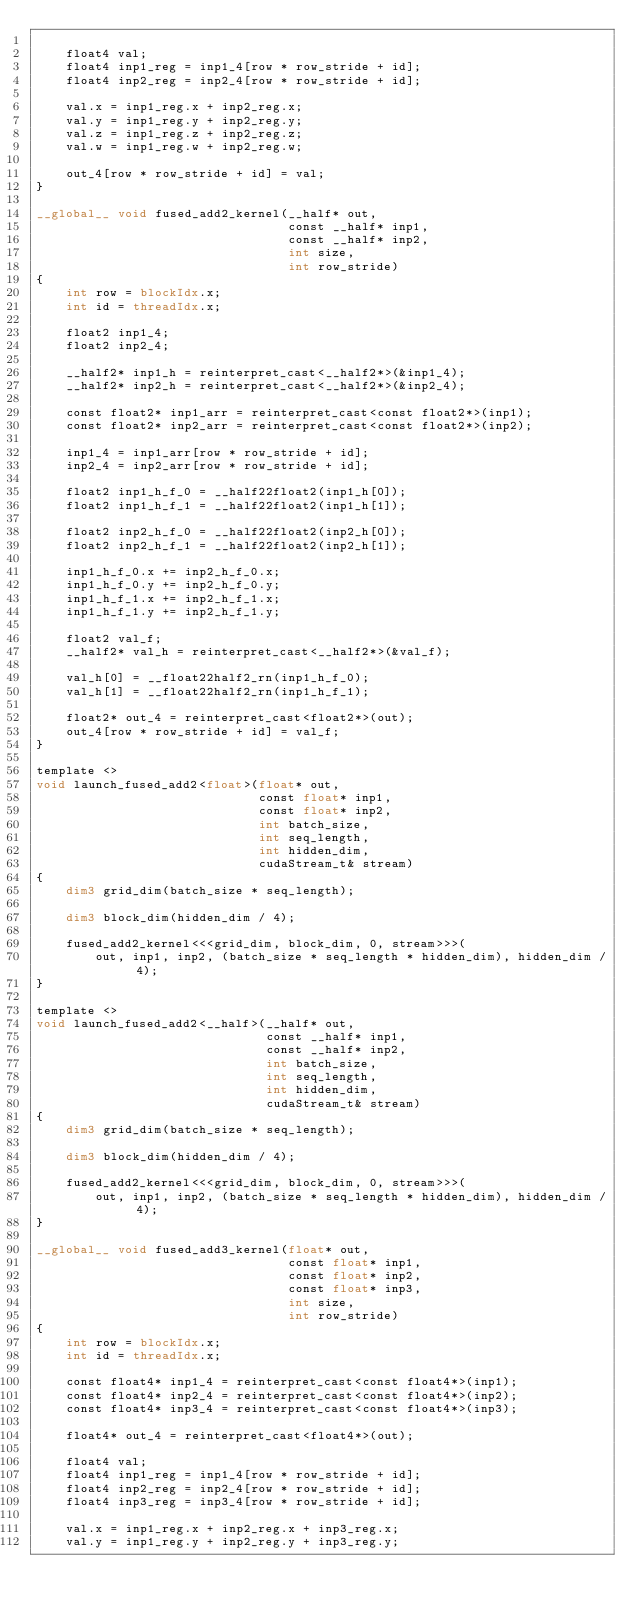<code> <loc_0><loc_0><loc_500><loc_500><_Cuda_>
    float4 val;
    float4 inp1_reg = inp1_4[row * row_stride + id];
    float4 inp2_reg = inp2_4[row * row_stride + id];

    val.x = inp1_reg.x + inp2_reg.x;
    val.y = inp1_reg.y + inp2_reg.y;
    val.z = inp1_reg.z + inp2_reg.z;
    val.w = inp1_reg.w + inp2_reg.w;

    out_4[row * row_stride + id] = val;
}

__global__ void fused_add2_kernel(__half* out,
                                  const __half* inp1,
                                  const __half* inp2,
                                  int size,
                                  int row_stride)
{
    int row = blockIdx.x;
    int id = threadIdx.x;

    float2 inp1_4;
    float2 inp2_4;

    __half2* inp1_h = reinterpret_cast<__half2*>(&inp1_4);
    __half2* inp2_h = reinterpret_cast<__half2*>(&inp2_4);

    const float2* inp1_arr = reinterpret_cast<const float2*>(inp1);
    const float2* inp2_arr = reinterpret_cast<const float2*>(inp2);

    inp1_4 = inp1_arr[row * row_stride + id];
    inp2_4 = inp2_arr[row * row_stride + id];

    float2 inp1_h_f_0 = __half22float2(inp1_h[0]);
    float2 inp1_h_f_1 = __half22float2(inp1_h[1]);

    float2 inp2_h_f_0 = __half22float2(inp2_h[0]);
    float2 inp2_h_f_1 = __half22float2(inp2_h[1]);

    inp1_h_f_0.x += inp2_h_f_0.x;
    inp1_h_f_0.y += inp2_h_f_0.y;
    inp1_h_f_1.x += inp2_h_f_1.x;
    inp1_h_f_1.y += inp2_h_f_1.y;

    float2 val_f;
    __half2* val_h = reinterpret_cast<__half2*>(&val_f);

    val_h[0] = __float22half2_rn(inp1_h_f_0);
    val_h[1] = __float22half2_rn(inp1_h_f_1);

    float2* out_4 = reinterpret_cast<float2*>(out);
    out_4[row * row_stride + id] = val_f;
}

template <>
void launch_fused_add2<float>(float* out,
                              const float* inp1,
                              const float* inp2,
                              int batch_size,
                              int seq_length,
                              int hidden_dim,
                              cudaStream_t& stream)
{
    dim3 grid_dim(batch_size * seq_length);

    dim3 block_dim(hidden_dim / 4);

    fused_add2_kernel<<<grid_dim, block_dim, 0, stream>>>(
        out, inp1, inp2, (batch_size * seq_length * hidden_dim), hidden_dim / 4);
}

template <>
void launch_fused_add2<__half>(__half* out,
                               const __half* inp1,
                               const __half* inp2,
                               int batch_size,
                               int seq_length,
                               int hidden_dim,
                               cudaStream_t& stream)
{
    dim3 grid_dim(batch_size * seq_length);

    dim3 block_dim(hidden_dim / 4);

    fused_add2_kernel<<<grid_dim, block_dim, 0, stream>>>(
        out, inp1, inp2, (batch_size * seq_length * hidden_dim), hidden_dim / 4);
}

__global__ void fused_add3_kernel(float* out,
                                  const float* inp1,
                                  const float* inp2,
                                  const float* inp3,
                                  int size,
                                  int row_stride)
{
    int row = blockIdx.x;
    int id = threadIdx.x;

    const float4* inp1_4 = reinterpret_cast<const float4*>(inp1);
    const float4* inp2_4 = reinterpret_cast<const float4*>(inp2);
    const float4* inp3_4 = reinterpret_cast<const float4*>(inp3);

    float4* out_4 = reinterpret_cast<float4*>(out);

    float4 val;
    float4 inp1_reg = inp1_4[row * row_stride + id];
    float4 inp2_reg = inp2_4[row * row_stride + id];
    float4 inp3_reg = inp3_4[row * row_stride + id];

    val.x = inp1_reg.x + inp2_reg.x + inp3_reg.x;
    val.y = inp1_reg.y + inp2_reg.y + inp3_reg.y;</code> 